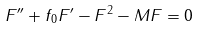<formula> <loc_0><loc_0><loc_500><loc_500>F ^ { \prime \prime } + f _ { 0 } F ^ { \prime } - F ^ { 2 } - M F = 0</formula> 